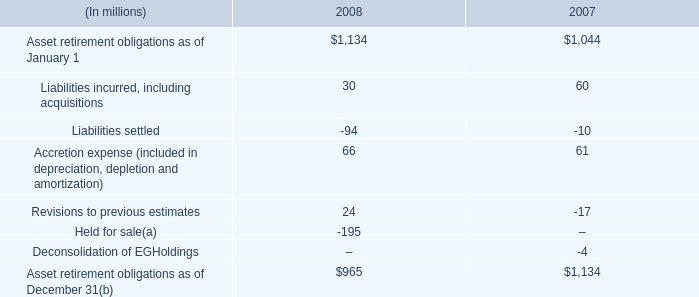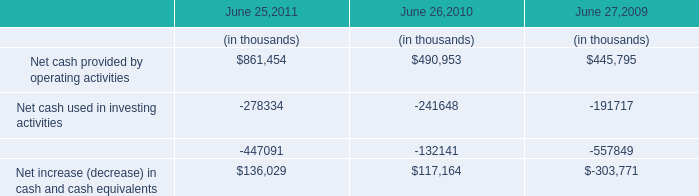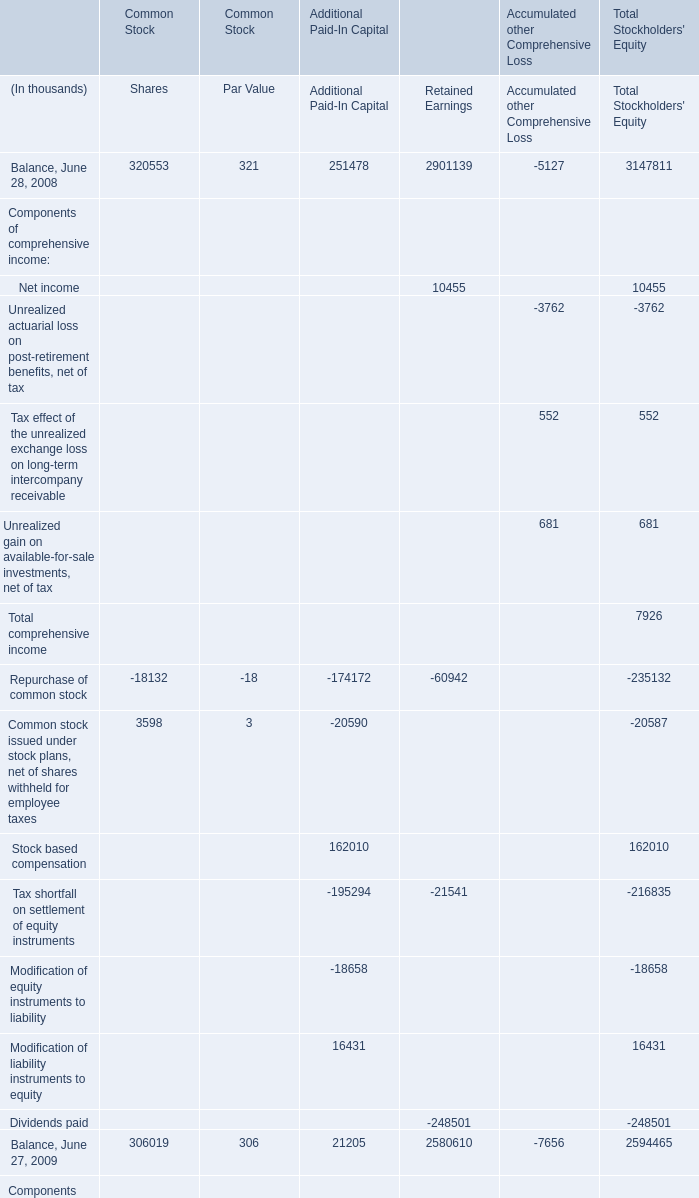What do all Additional Paid-In Capital sum up, excluding those negative ones in 2009? (in thousand) 
Computations: (((21205 + 3512) + 90440) + 24770)
Answer: 139927.0. 